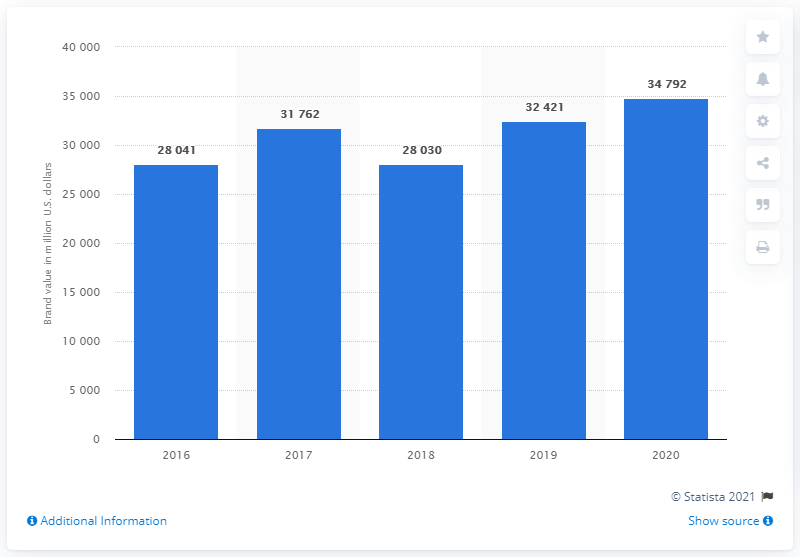Give some essential details in this illustration. In 2020, Nike was valued at approximately 34.8 billion U.S. dollars. Nike's value increased significantly from 2019, as evidenced by the 34,792-dollar figure provided. In 2020, Nike's value was 34,792 dollars. 